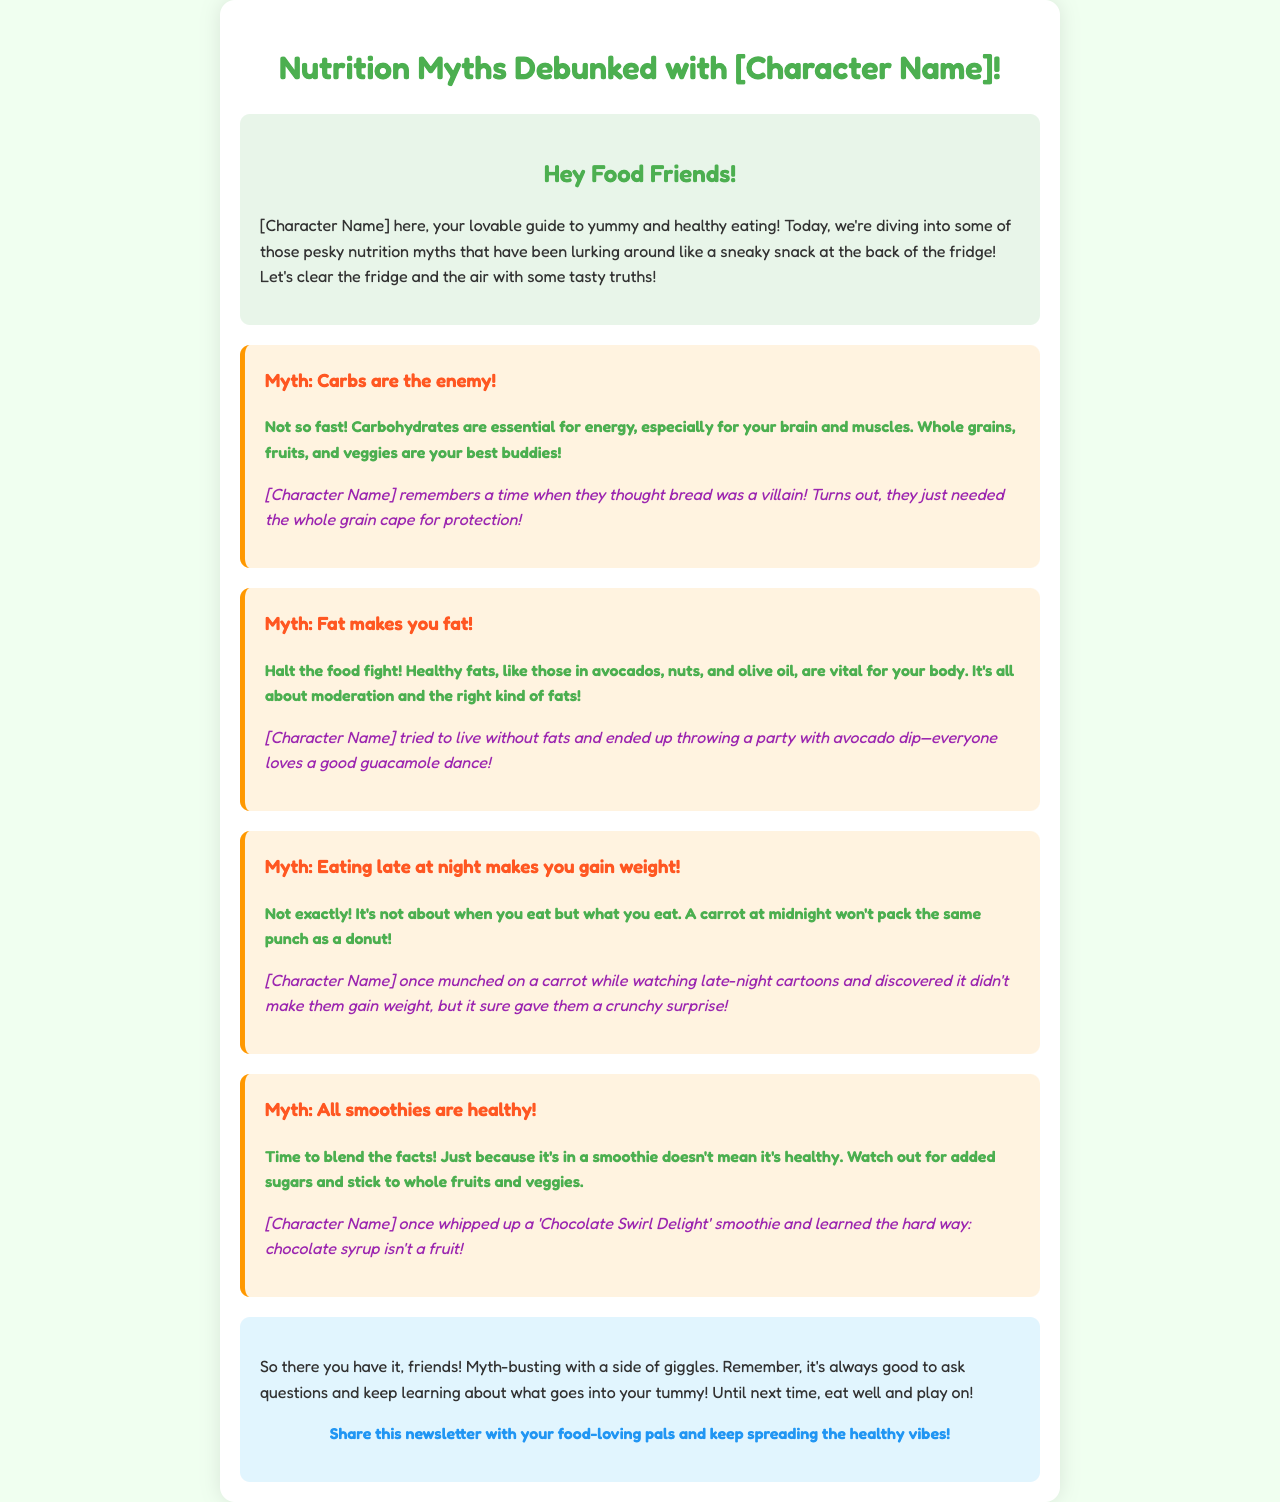What is the title of the newsletter? The title of the newsletter is given in the `<title>` tag within the document, which is "Nutrition Myths Debunked with [Character Name]!"
Answer: Nutrition Myths Debunked with [Character Name]! Who is the guide to healthy eating in the newsletter? The character introducing the newsletter serves as the guide to healthy eating, as mentioned in the introduction section.
Answer: [Character Name] What myth is associated with carbohydrates? One of the myths addresses carbohydrates negatively, as stated in the myth section of the document.
Answer: Carbs are the enemy! What healthy fat sources are mentioned? The document lists specific healthy fat sources in the myth about fat, which includes a variety of food items.
Answer: Avocados, nuts, and olive oil What late-night snack was mentioned in the document? The anecdote in the myth about eating late describes a specific late-night snack consumed by the character.
Answer: A carrot How can smoothies be unhealthy? One of the myths discusses the health aspects of smoothies, illustrating a specific reason why they can be unhealthy based on the content of the document.
Answer: Added sugars What lively event did [Character Name] mention while discussing fats? The character shares a personal experience related to a food-related event while discussing healthy fats in the newsletter.
Answer: Guacamole dance What should be shared according to the call to action? The final statement in the document encourages sharing the content with others to promote healthy habits.
Answer: This newsletter 